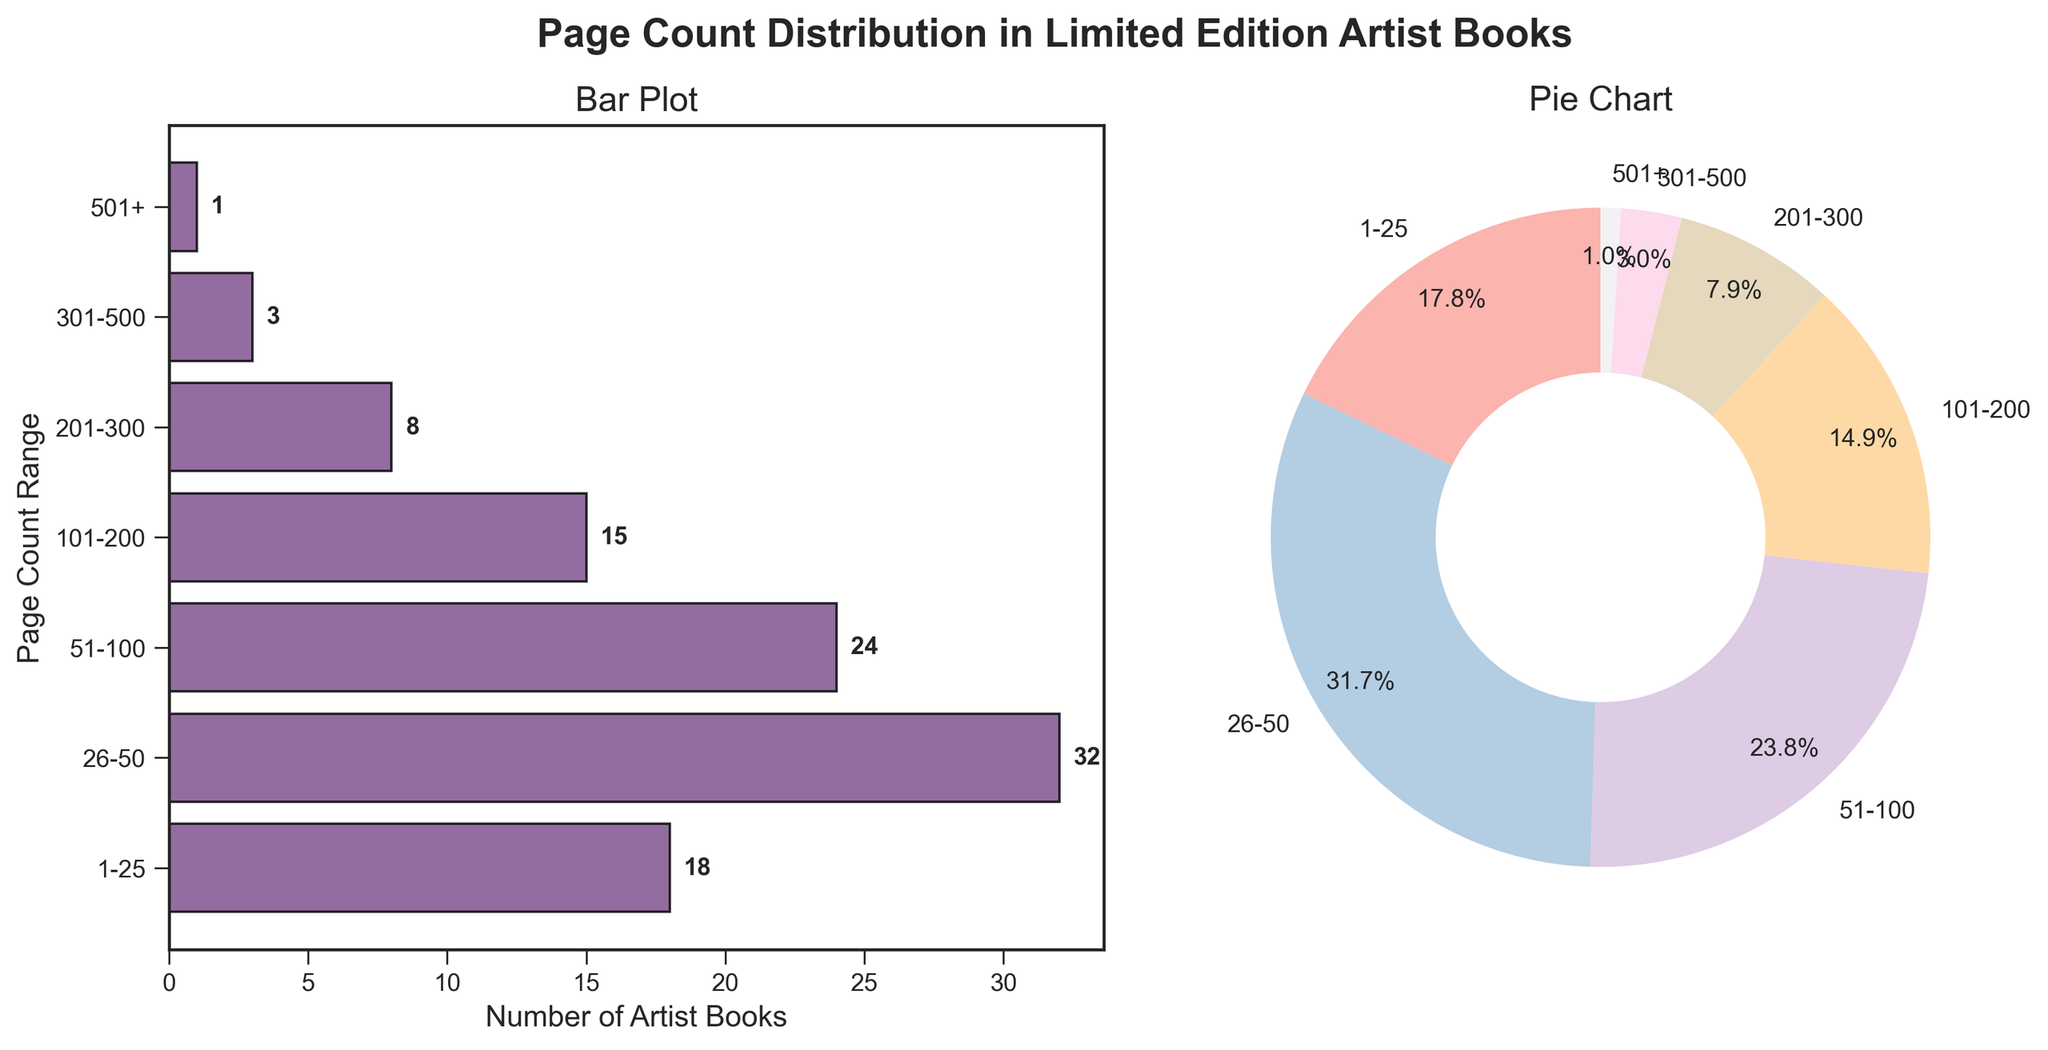What's the title of the figure? The title is located at the top of the figure and is bolded. It mentions the distribution of page counts in limited edition artist books.
Answer: Page Count Distribution in Limited Edition Artist Books Which page count range has the highest number of artist books? The horizontal bar that extends the farthest to the right represents the range with the highest number of artist books.
Answer: 26-50 What percentage of artist books have a page count range of 26-50? In the pie chart, look for the size and the percentage label for the 26-50 range.
Answer: 34.8% How many artist books have more than 500 pages? From the bar plot, the bar corresponding to the "501+" range indicates the number of artist books with more than 500 pages.
Answer: 1 Is the number of artist books with a page count of 1-25 higher or lower than those with 101-200 pages? Comparing the lengths of the bars for ranges 1-25 and 101-200 will show which is larger.
Answer: Higher What's the total number of artist books covered in this figure? Add the number of all artist books from each page count range. 18 + 32 + 24 + 15 + 8 + 3 + 1 = 101
Answer: 101 What is the smallest range of page counts with more than 20 artist books? Identify ranges with more than 20 artist books and select the smallest range. The "26-50" and "51-100" ranges qualify; the smallest is "26-50".
Answer: 26-50 Which page count range has the smallest slice in the pie chart? The smallest wedge in the pie chart corresponds to the range with the fewest number of artist books.
Answer: 501+ How many artist books have a page count range of 101-500? Add the numbers for the ranges 101-200, 201-300, and 301-500. 15 + 8 + 3 = 26
Answer: 26 